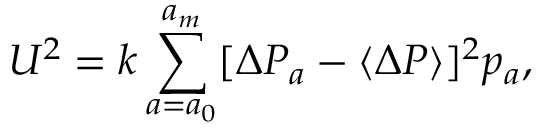<formula> <loc_0><loc_0><loc_500><loc_500>U ^ { 2 } = k \sum _ { a = a _ { 0 } } ^ { a _ { m } } [ \Delta P _ { a } - \langle \Delta P \rangle ] ^ { 2 } p _ { a } ,</formula> 